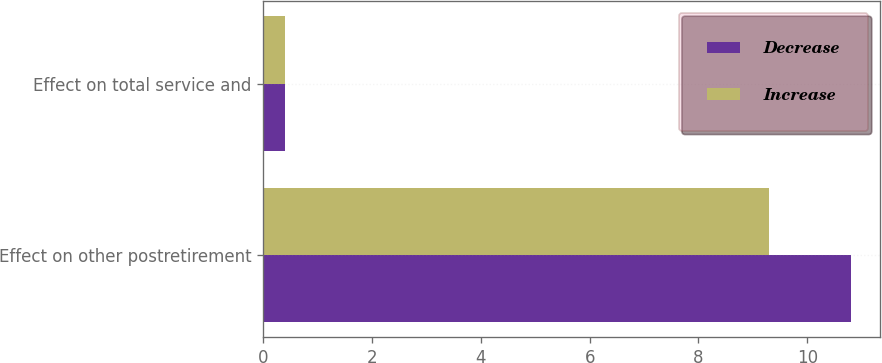<chart> <loc_0><loc_0><loc_500><loc_500><stacked_bar_chart><ecel><fcel>Effect on other postretirement<fcel>Effect on total service and<nl><fcel>Decrease<fcel>10.8<fcel>0.4<nl><fcel>Increase<fcel>9.3<fcel>0.4<nl></chart> 